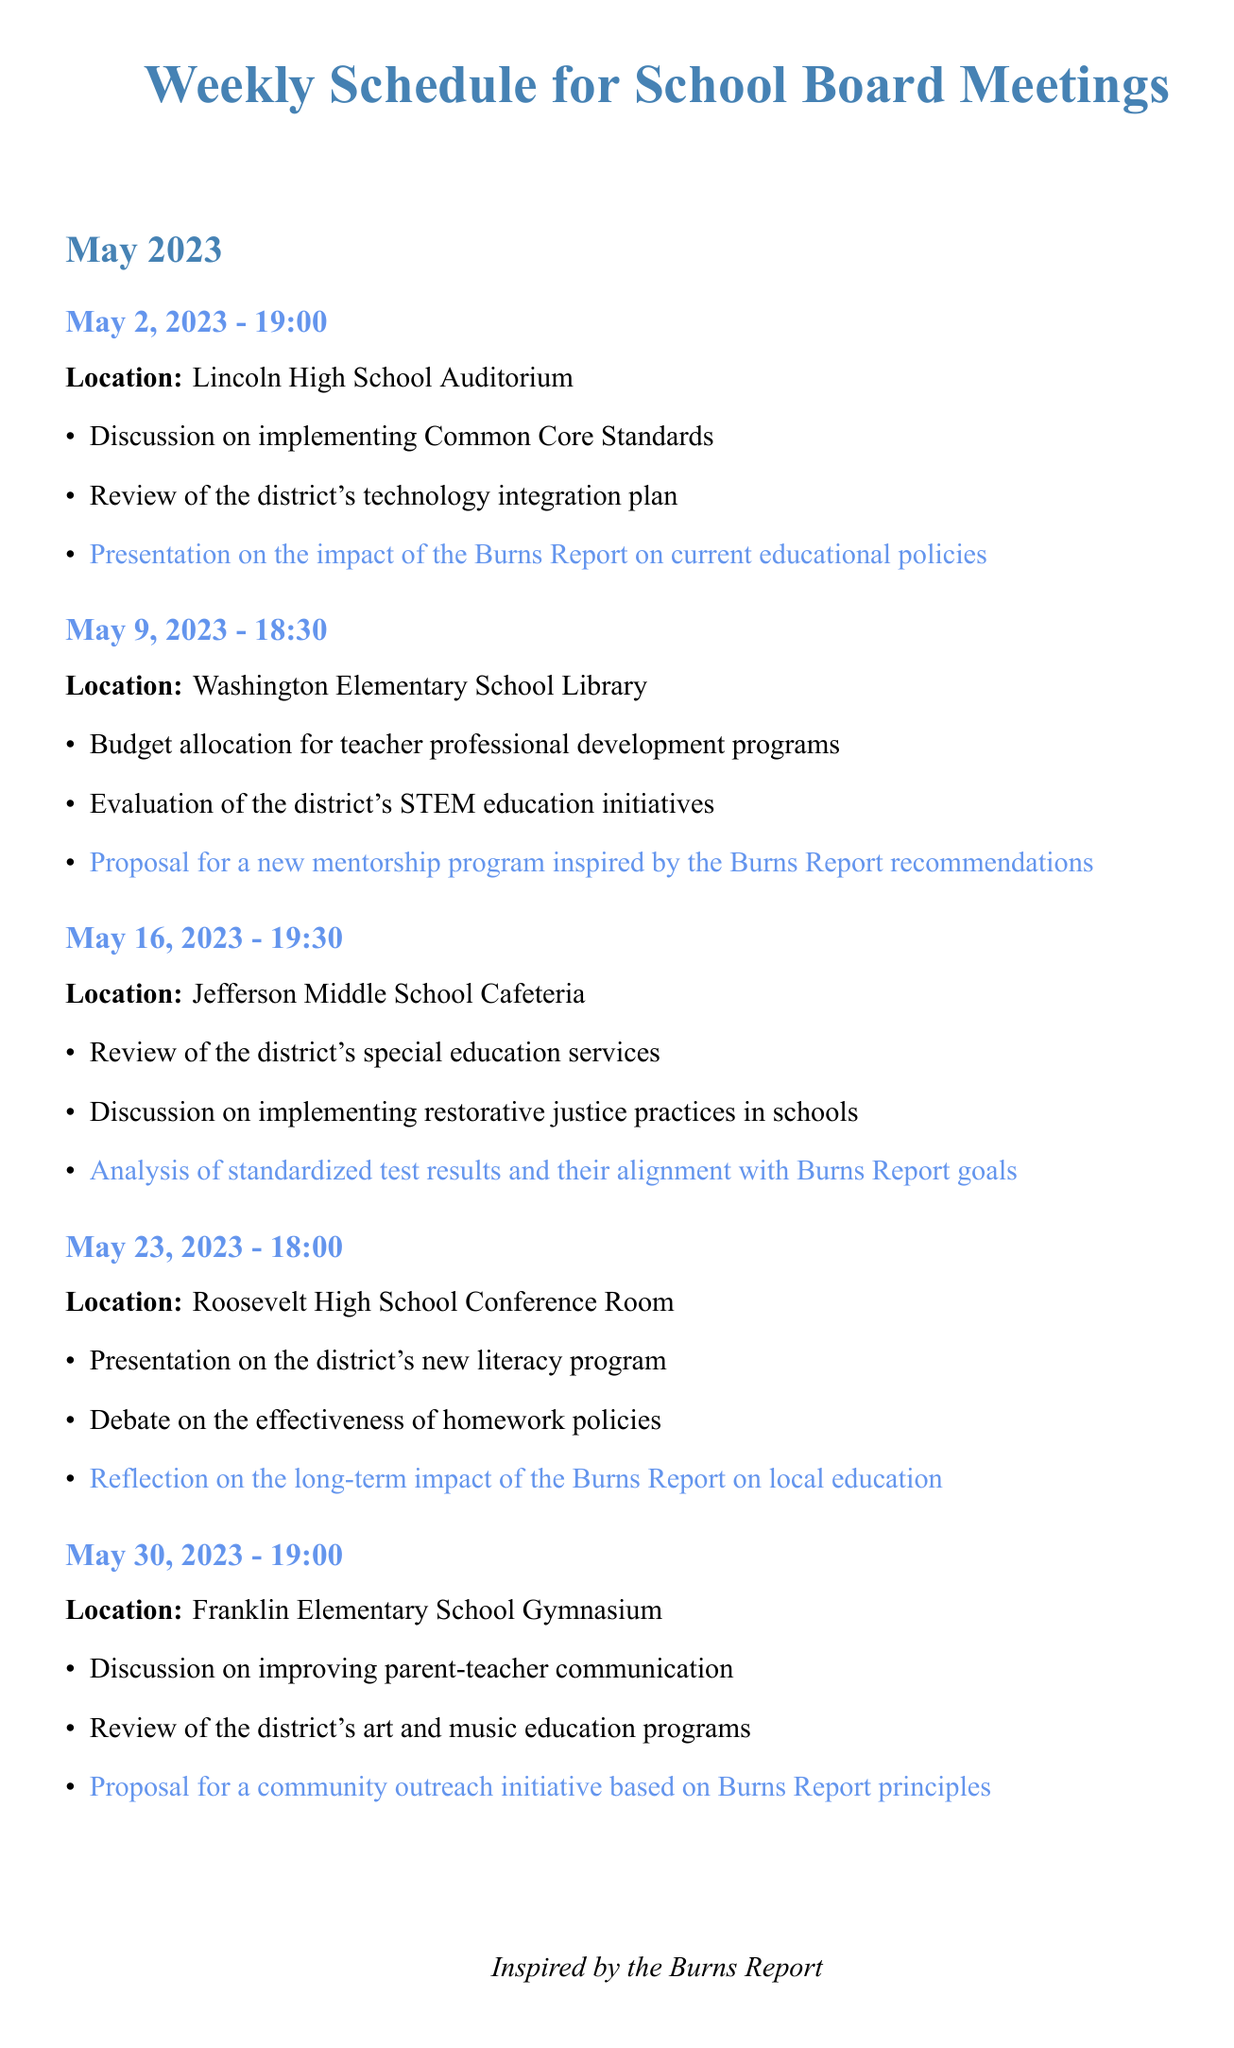What is the date of the first school board meeting? The first school board meeting listed in the document is on May 2, 2023.
Answer: May 2, 2023 Where will the meeting on May 16, 2023, be held? The location for the meeting on May 16, 2023, is specified as Jefferson Middle School Cafeteria.
Answer: Jefferson Middle School Cafeteria How many agenda items will be discussed on May 30, 2023? The document lists three agenda items for the meeting on May 30, 2023.
Answer: Three What is one of the topics related to the Burns Report scheduled for the meeting on May 9, 2023? The agenda for May 9, 2023, includes a proposal for a new mentorship program inspired by the Burns Report recommendations.
Answer: Proposal for a new mentorship program Which board member is the Treasurer? The document identifies Linda Martinez as the Treasurer.
Answer: Linda Martinez What is the time of the meeting scheduled for May 23, 2023? The meeting on May 23, 2023, is scheduled to begin at 18:00.
Answer: 18:00 What is the public comment policy as described in the document? The policy states that members of the public can speak for up to 3 minutes on any agenda item or other matter of concern.
Answer: Up to 3 minutes What is stated about the accessibility of the meetings? The document mentions that all meetings are wheelchair accessible.
Answer: Wheelchair accessible 